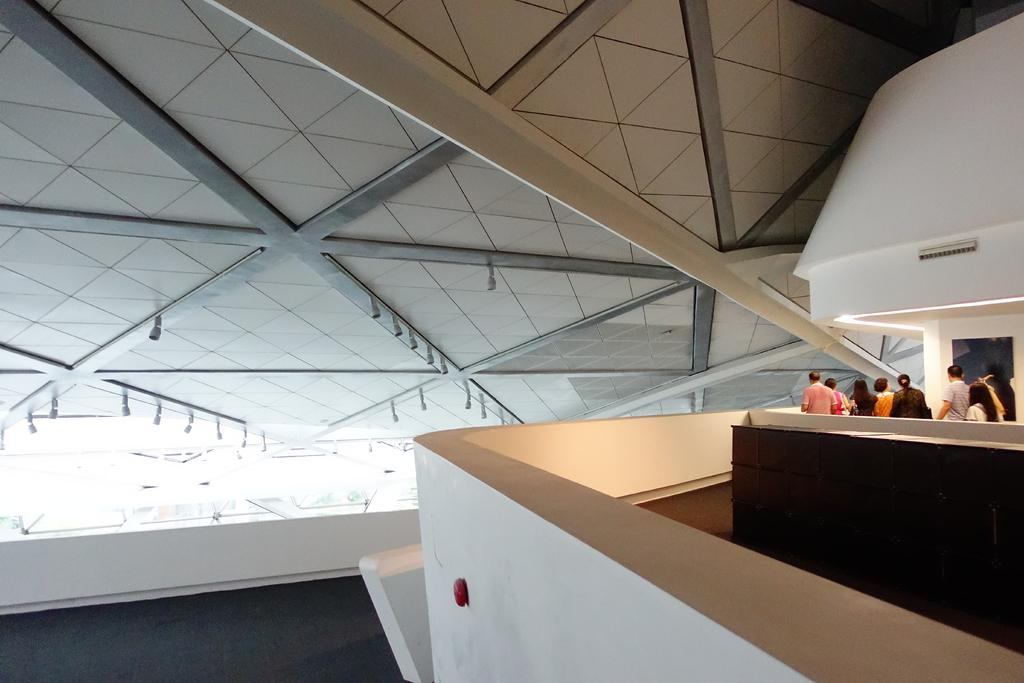What can be seen in the image regarding the people's attire? There is a group of people with different color dresses present in the image. What is visible in the background of the image? There is a wall visible in the image. Where are the people located in the image? The people are inside a building. What type of lumber is being used to support the ceiling in the image? There is no visible lumber or ceiling in the image, so it is not possible to determine the type of lumber being used. 